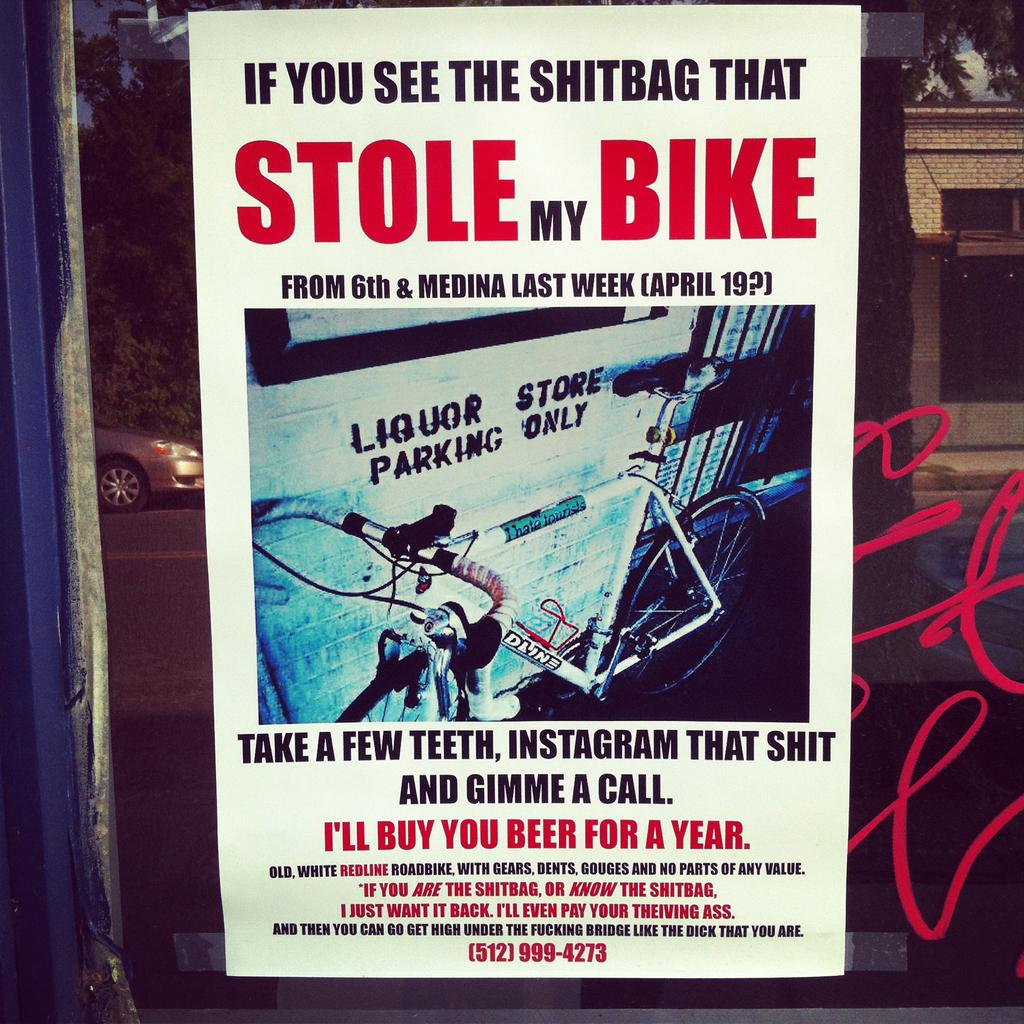<image>
Write a terse but informative summary of the picture. Poster of someone looking for the person that Stole their Bike. 